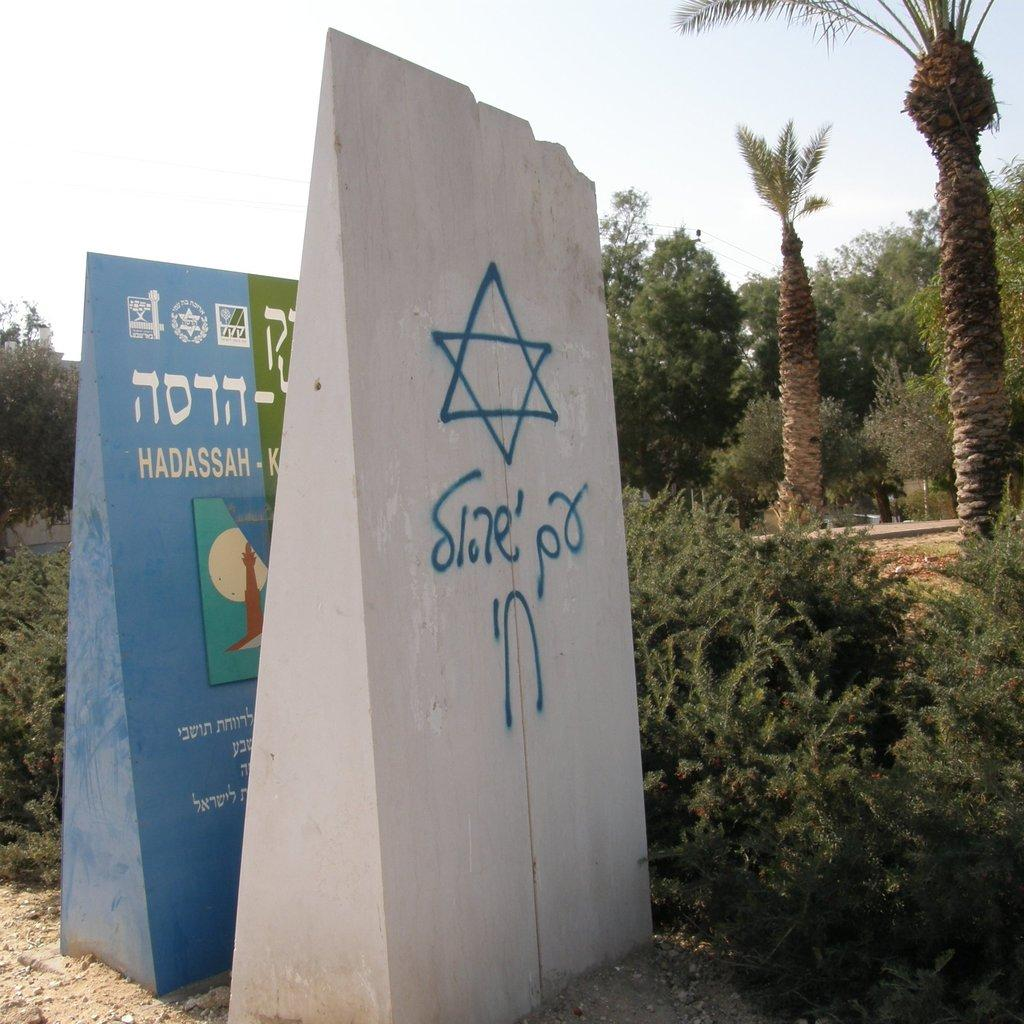How many wall structures can be seen in the image? There are two wall structures in the image. What is featured on the wall structures? There is text and images on the wall structures. What can be seen in the background of the image? There are trees and the sky visible in the background of the image. What type of skirt is hanging from the wall structure in the image? There is no skirt present in the image; the wall structures have text and images on them. 